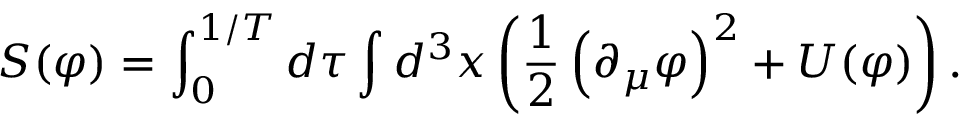Convert formula to latex. <formula><loc_0><loc_0><loc_500><loc_500>S ( \varphi ) = \int _ { 0 } ^ { 1 / T } d \tau \int d ^ { 3 } x \left ( { \frac { 1 } { 2 } } \left ( \partial _ { \mu } \varphi \right ) ^ { 2 } + U ( \varphi ) \right ) .</formula> 